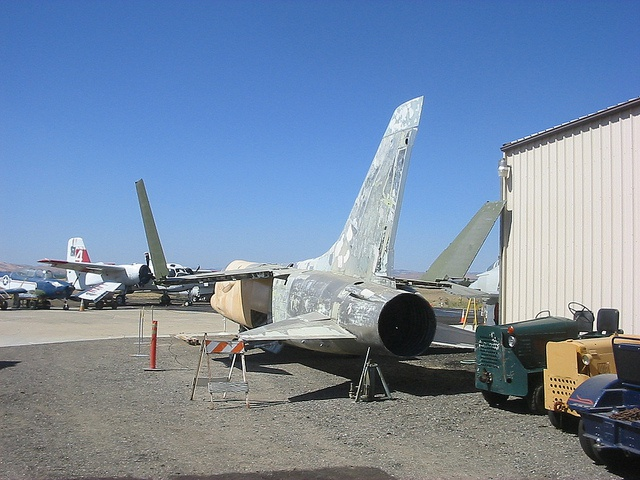Describe the objects in this image and their specific colors. I can see airplane in blue, darkgray, lightgray, black, and gray tones, airplane in blue, white, gray, black, and darkgray tones, and airplane in blue, black, gray, and lightgray tones in this image. 